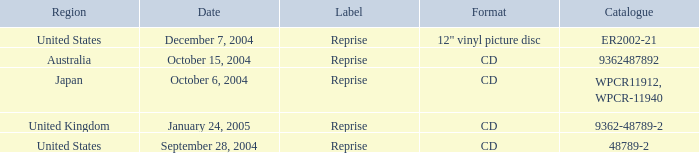What items were listed in the catalog on october 15, 2004? 9362487892.0. 